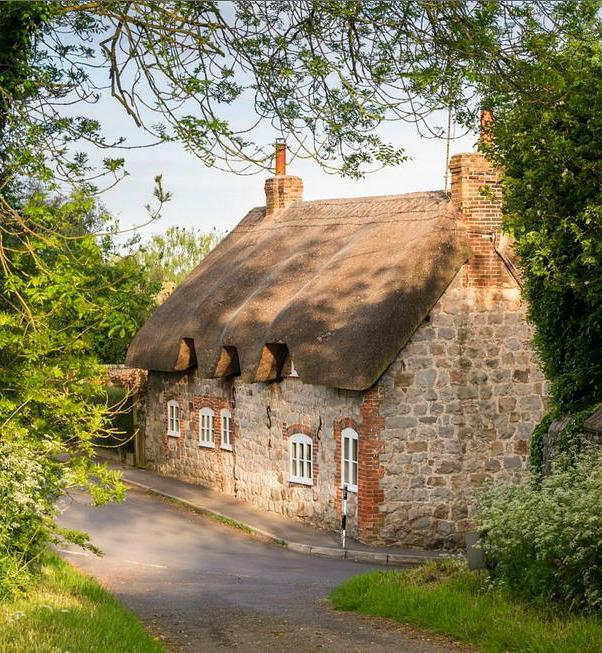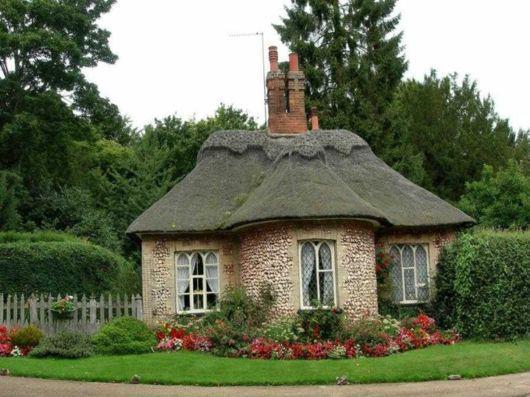The first image is the image on the left, the second image is the image on the right. Evaluate the accuracy of this statement regarding the images: "The right image shows a house with windows featuring different shaped panes below a thick gray roof with a rounded section in front and a scalloped border on the peak edge.". Is it true? Answer yes or no. Yes. 